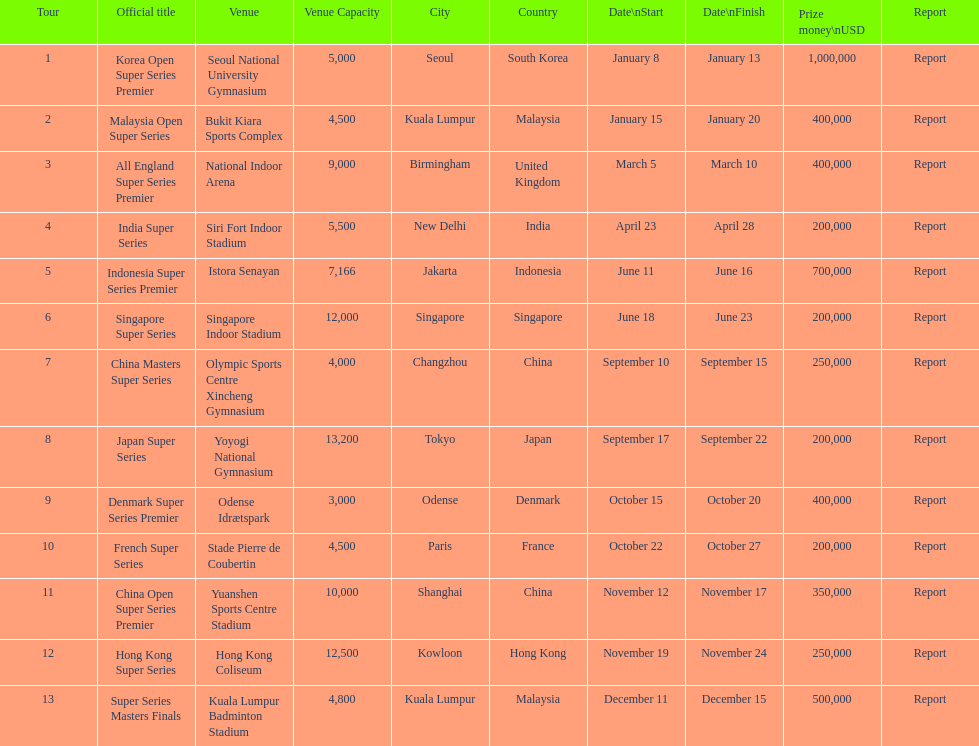How many days does the japan super series last? 5. 